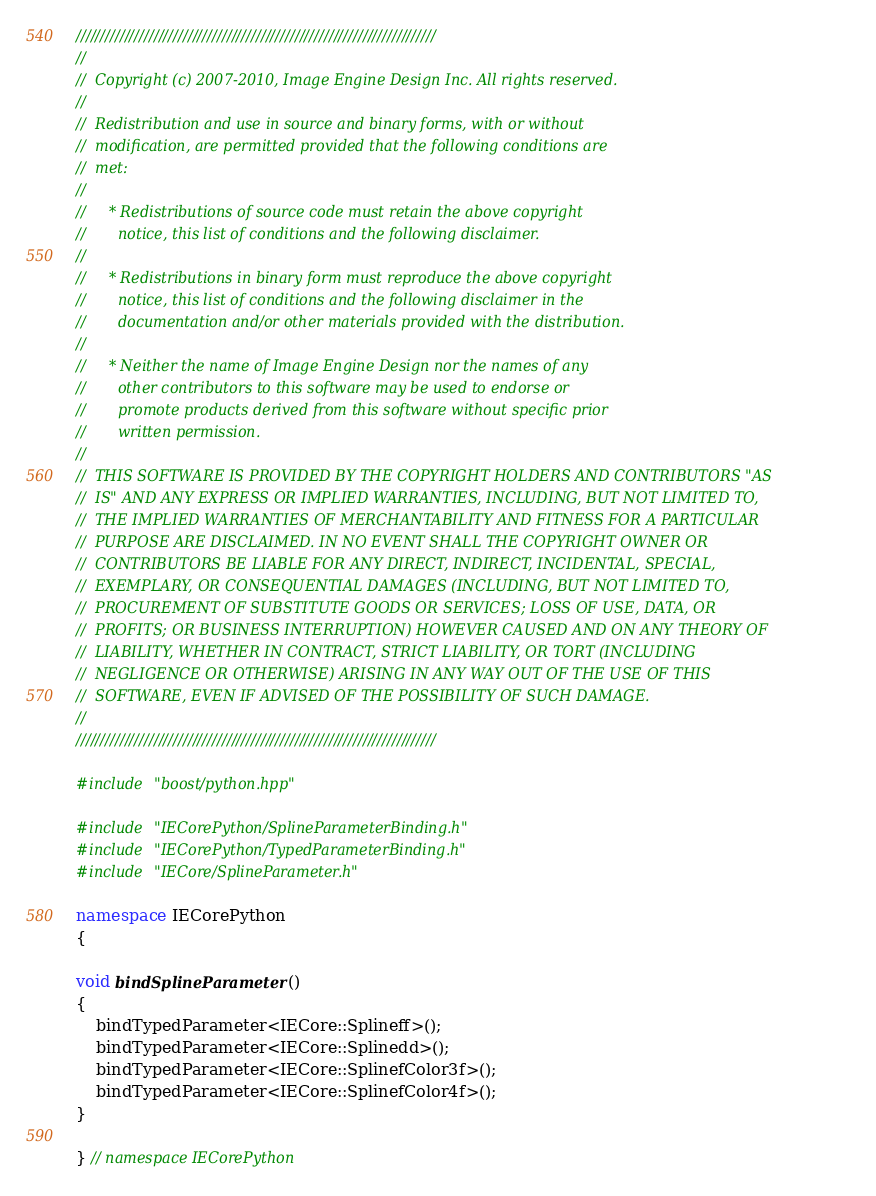<code> <loc_0><loc_0><loc_500><loc_500><_C++_>//////////////////////////////////////////////////////////////////////////
//
//  Copyright (c) 2007-2010, Image Engine Design Inc. All rights reserved.
//
//  Redistribution and use in source and binary forms, with or without
//  modification, are permitted provided that the following conditions are
//  met:
//
//     * Redistributions of source code must retain the above copyright
//       notice, this list of conditions and the following disclaimer.
//
//     * Redistributions in binary form must reproduce the above copyright
//       notice, this list of conditions and the following disclaimer in the
//       documentation and/or other materials provided with the distribution.
//
//     * Neither the name of Image Engine Design nor the names of any
//       other contributors to this software may be used to endorse or
//       promote products derived from this software without specific prior
//       written permission.
//
//  THIS SOFTWARE IS PROVIDED BY THE COPYRIGHT HOLDERS AND CONTRIBUTORS "AS
//  IS" AND ANY EXPRESS OR IMPLIED WARRANTIES, INCLUDING, BUT NOT LIMITED TO,
//  THE IMPLIED WARRANTIES OF MERCHANTABILITY AND FITNESS FOR A PARTICULAR
//  PURPOSE ARE DISCLAIMED. IN NO EVENT SHALL THE COPYRIGHT OWNER OR
//  CONTRIBUTORS BE LIABLE FOR ANY DIRECT, INDIRECT, INCIDENTAL, SPECIAL,
//  EXEMPLARY, OR CONSEQUENTIAL DAMAGES (INCLUDING, BUT NOT LIMITED TO,
//  PROCUREMENT OF SUBSTITUTE GOODS OR SERVICES; LOSS OF USE, DATA, OR
//  PROFITS; OR BUSINESS INTERRUPTION) HOWEVER CAUSED AND ON ANY THEORY OF
//  LIABILITY, WHETHER IN CONTRACT, STRICT LIABILITY, OR TORT (INCLUDING
//  NEGLIGENCE OR OTHERWISE) ARISING IN ANY WAY OUT OF THE USE OF THIS
//  SOFTWARE, EVEN IF ADVISED OF THE POSSIBILITY OF SUCH DAMAGE.
//
//////////////////////////////////////////////////////////////////////////

#include "boost/python.hpp"

#include "IECorePython/SplineParameterBinding.h"
#include "IECorePython/TypedParameterBinding.h"
#include "IECore/SplineParameter.h"

namespace IECorePython
{

void bindSplineParameter()
{
	bindTypedParameter<IECore::Splineff>();
	bindTypedParameter<IECore::Splinedd>();
	bindTypedParameter<IECore::SplinefColor3f>();
	bindTypedParameter<IECore::SplinefColor4f>();
}

} // namespace IECorePython
</code> 